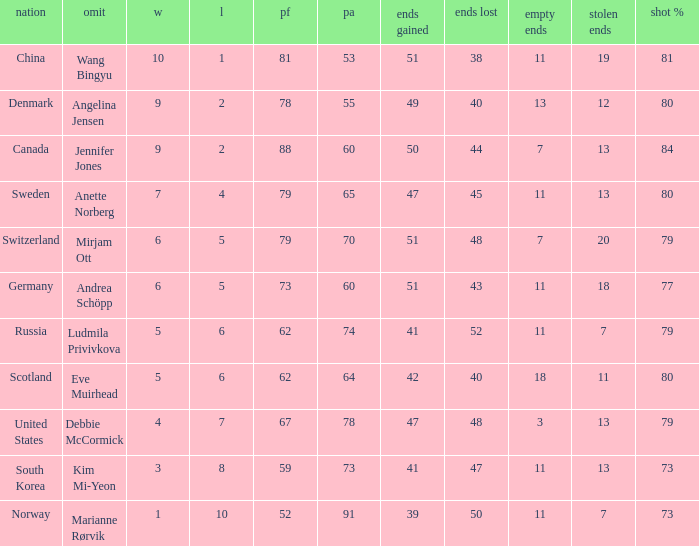What is the minimum Wins a team has? 1.0. 